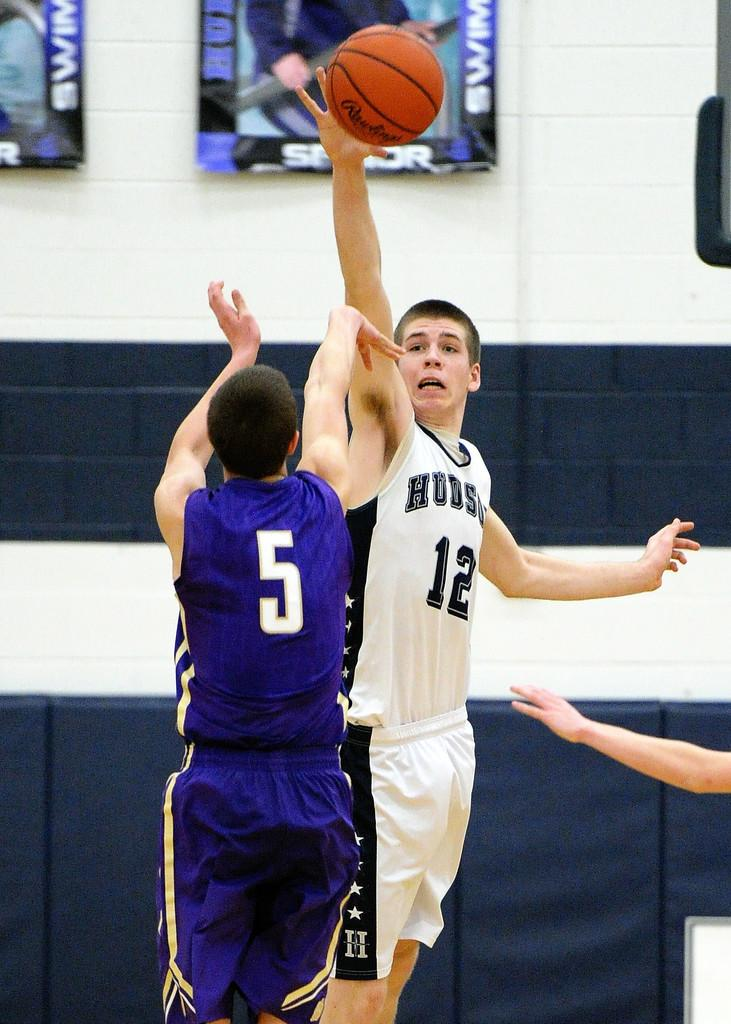Provide a one-sentence caption for the provided image. hudson basketball player #12 trying to block shot from purple player #5. 